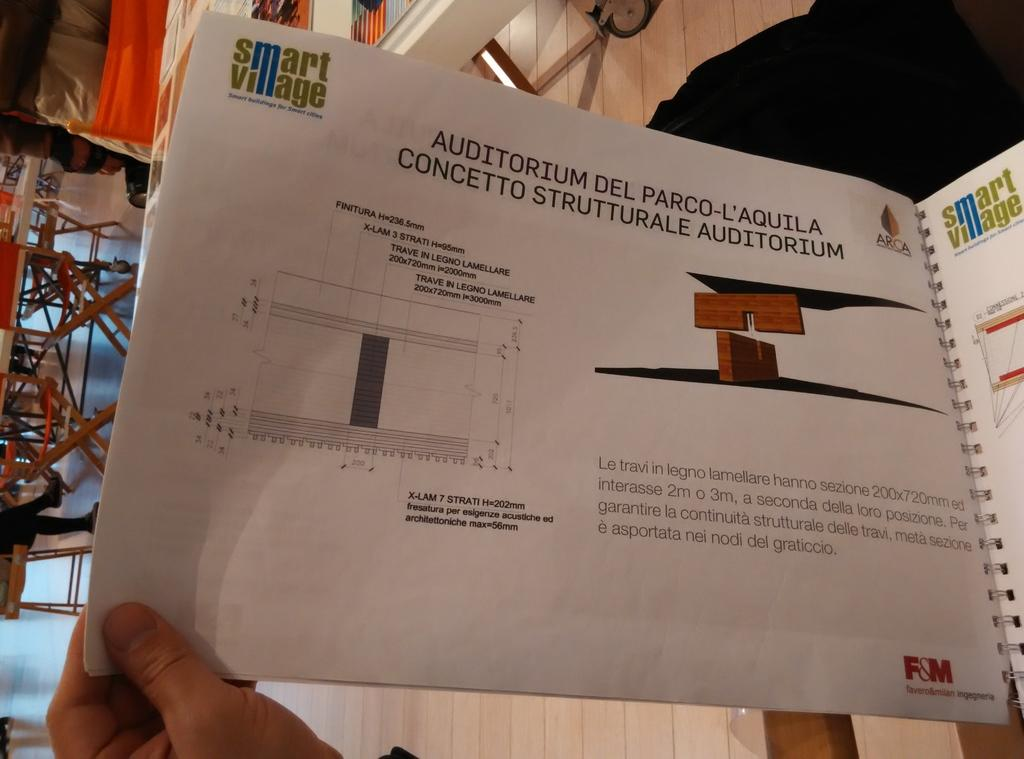<image>
Create a compact narrative representing the image presented. A person holding an instruction booklet that was made by Smart Village. 